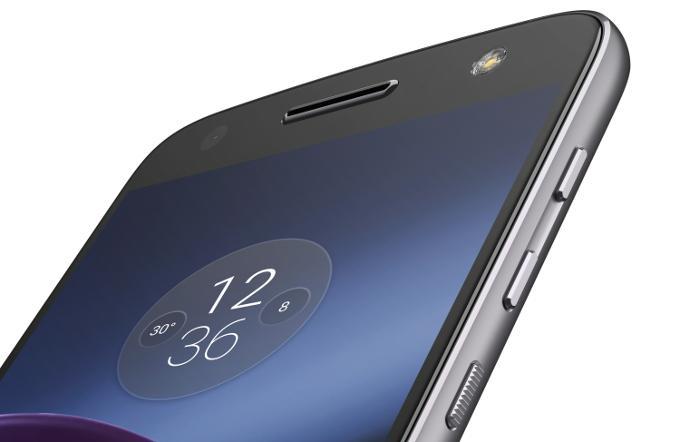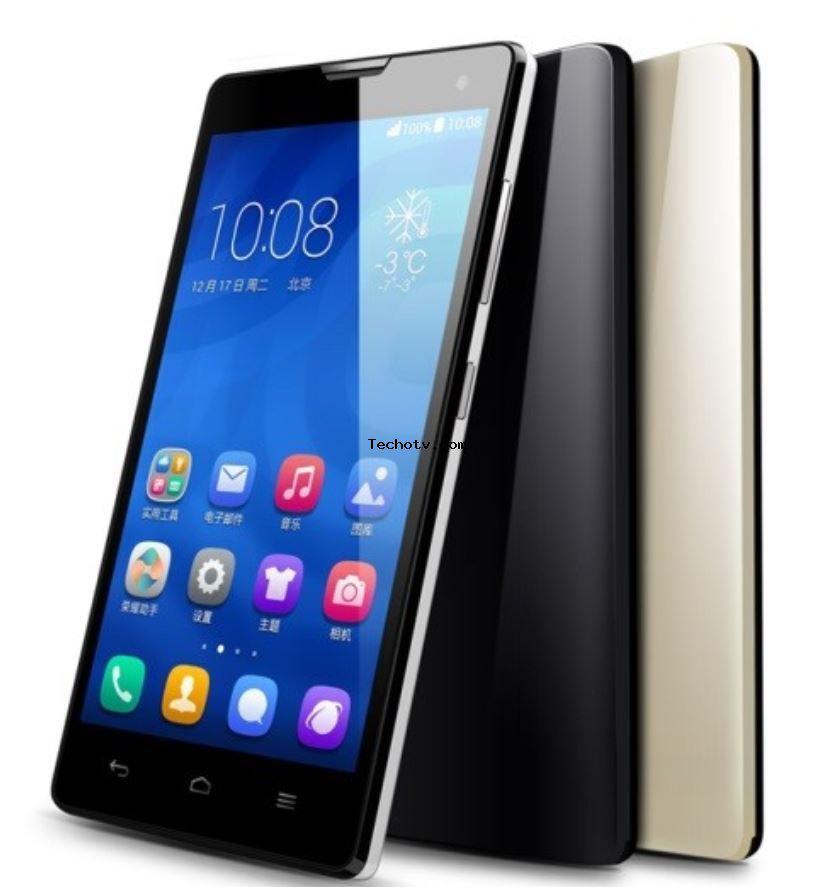The first image is the image on the left, the second image is the image on the right. Considering the images on both sides, is "One image contains exactly four phones, and the other image contains at least five phones." valid? Answer yes or no. No. The first image is the image on the left, the second image is the image on the right. Analyze the images presented: Is the assertion "Every image shows at least four devices and all screens show an image." valid? Answer yes or no. No. 